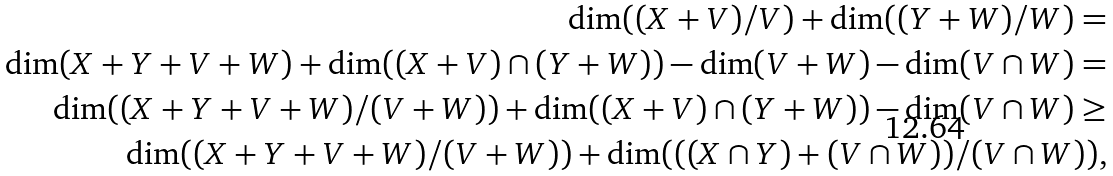<formula> <loc_0><loc_0><loc_500><loc_500>\dim ( ( X + V ) / V ) + \dim ( ( Y + W ) / W ) = \\ \dim ( X + Y + V + W ) + \dim ( ( X + V ) \cap ( Y + W ) ) - \dim ( V + W ) - \dim ( V \cap W ) = \\ \dim ( ( X + Y + V + W ) / ( V + W ) ) + \dim ( ( X + V ) \cap ( Y + W ) ) - \dim ( V \cap W ) \geq \\ \dim ( ( X + Y + V + W ) / ( V + W ) ) + \dim ( ( ( X \cap Y ) + ( V \cap W ) ) / ( V \cap W ) ) ,</formula> 